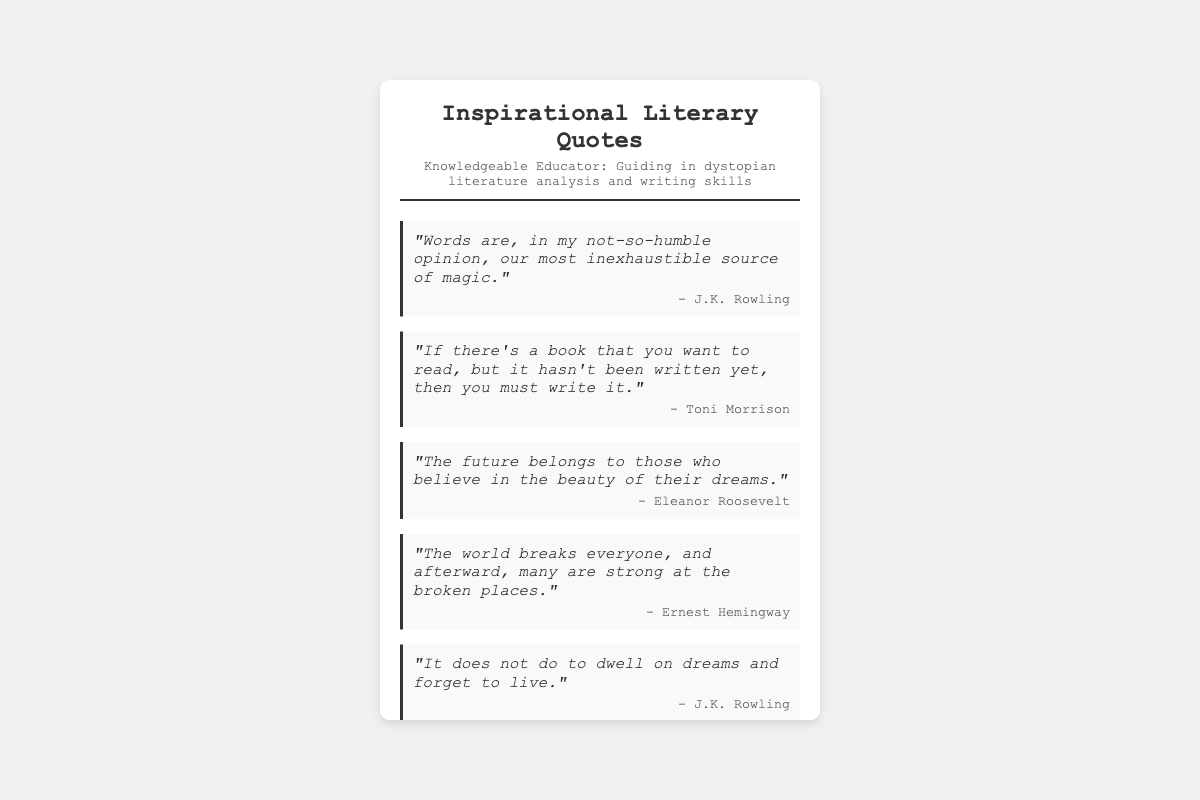What is the title of the document? The title of the document is indicated in the header section, specifically stated under the "title" class.
Answer: Inspirational Literary Quotes Who is the persona mentioned in the document? The persona is described in the header, providing insight into the role or identity related to the quotes.
Answer: Knowledgeable Educator How many quotes are included in the document? The total number of quotes is counted from the individual quote containers present in the document.
Answer: Five Who is the author of the second quote? The author is stated right below the respective quote in each container, specifically for the second quote in this case.
Answer: Toni Morrison What does the first quote refer to as a source? The first quote mentions "words" as a source, which is a key element of the message conveyed by J.K. Rowling.
Answer: magic Which author is quoted twice in the document? The author appears more than once based on the author names listed under each quote, indicating repetition.
Answer: J.K. Rowling What theme is prominent in the quotes presented? Analyzing the content of the quotes reveals a common theme that focuses on personal empowerment and belief.
Answer: Inspiration What design element separates the title from the quotes? The document includes a specific element that visually divides sections, enhancing clarity and organization.
Answer: border 